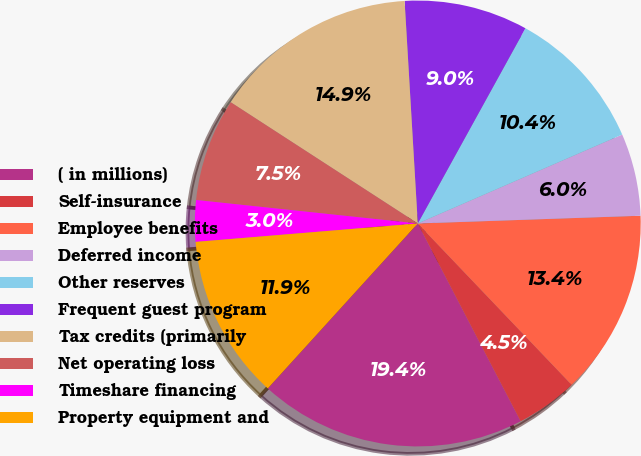Convert chart. <chart><loc_0><loc_0><loc_500><loc_500><pie_chart><fcel>( in millions)<fcel>Self-insurance<fcel>Employee benefits<fcel>Deferred income<fcel>Other reserves<fcel>Frequent guest program<fcel>Tax credits (primarily<fcel>Net operating loss<fcel>Timeshare financing<fcel>Property equipment and<nl><fcel>19.38%<fcel>4.49%<fcel>13.43%<fcel>5.98%<fcel>10.45%<fcel>8.96%<fcel>14.91%<fcel>7.47%<fcel>3.0%<fcel>11.94%<nl></chart> 